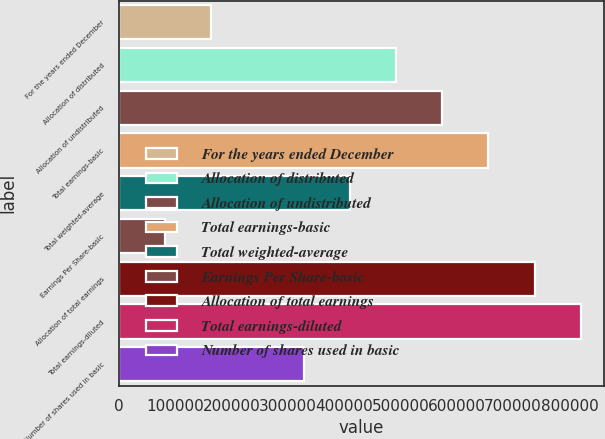Convert chart to OTSL. <chart><loc_0><loc_0><loc_500><loc_500><bar_chart><fcel>For the years ended December<fcel>Allocation of distributed<fcel>Allocation of undistributed<fcel>Total earnings-basic<fcel>Total weighted-average<fcel>Earnings Per Share-basic<fcel>Allocation of total earnings<fcel>Total earnings-diluted<fcel>Number of shares used in basic<nl><fcel>164097<fcel>492283<fcel>574330<fcel>656377<fcel>410237<fcel>82050.2<fcel>738423<fcel>820470<fcel>328190<nl></chart> 